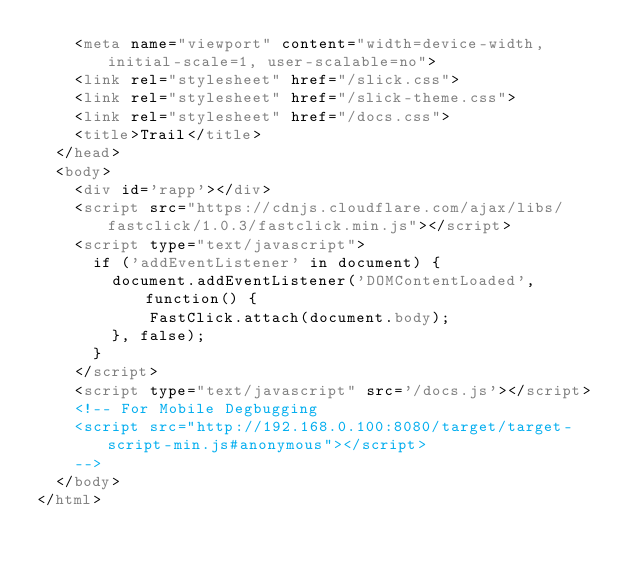<code> <loc_0><loc_0><loc_500><loc_500><_HTML_>    <meta name="viewport" content="width=device-width, initial-scale=1, user-scalable=no">
    <link rel="stylesheet" href="/slick.css">
    <link rel="stylesheet" href="/slick-theme.css">
    <link rel="stylesheet" href="/docs.css">
    <title>Trail</title>
  </head>
  <body>
    <div id='rapp'></div>
    <script src="https://cdnjs.cloudflare.com/ajax/libs/fastclick/1.0.3/fastclick.min.js"></script>
    <script type="text/javascript">
      if ('addEventListener' in document) {
        document.addEventListener('DOMContentLoaded', function() {
            FastClick.attach(document.body);
        }, false);
      }
    </script>
    <script type="text/javascript" src='/docs.js'></script>
    <!-- For Mobile Degbugging
    <script src="http://192.168.0.100:8080/target/target-script-min.js#anonymous"></script>
    -->
  </body>
</html>
</code> 